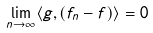<formula> <loc_0><loc_0><loc_500><loc_500>\lim _ { n \to \infty } \langle g , ( f _ { n } - f ) \rangle = 0</formula> 